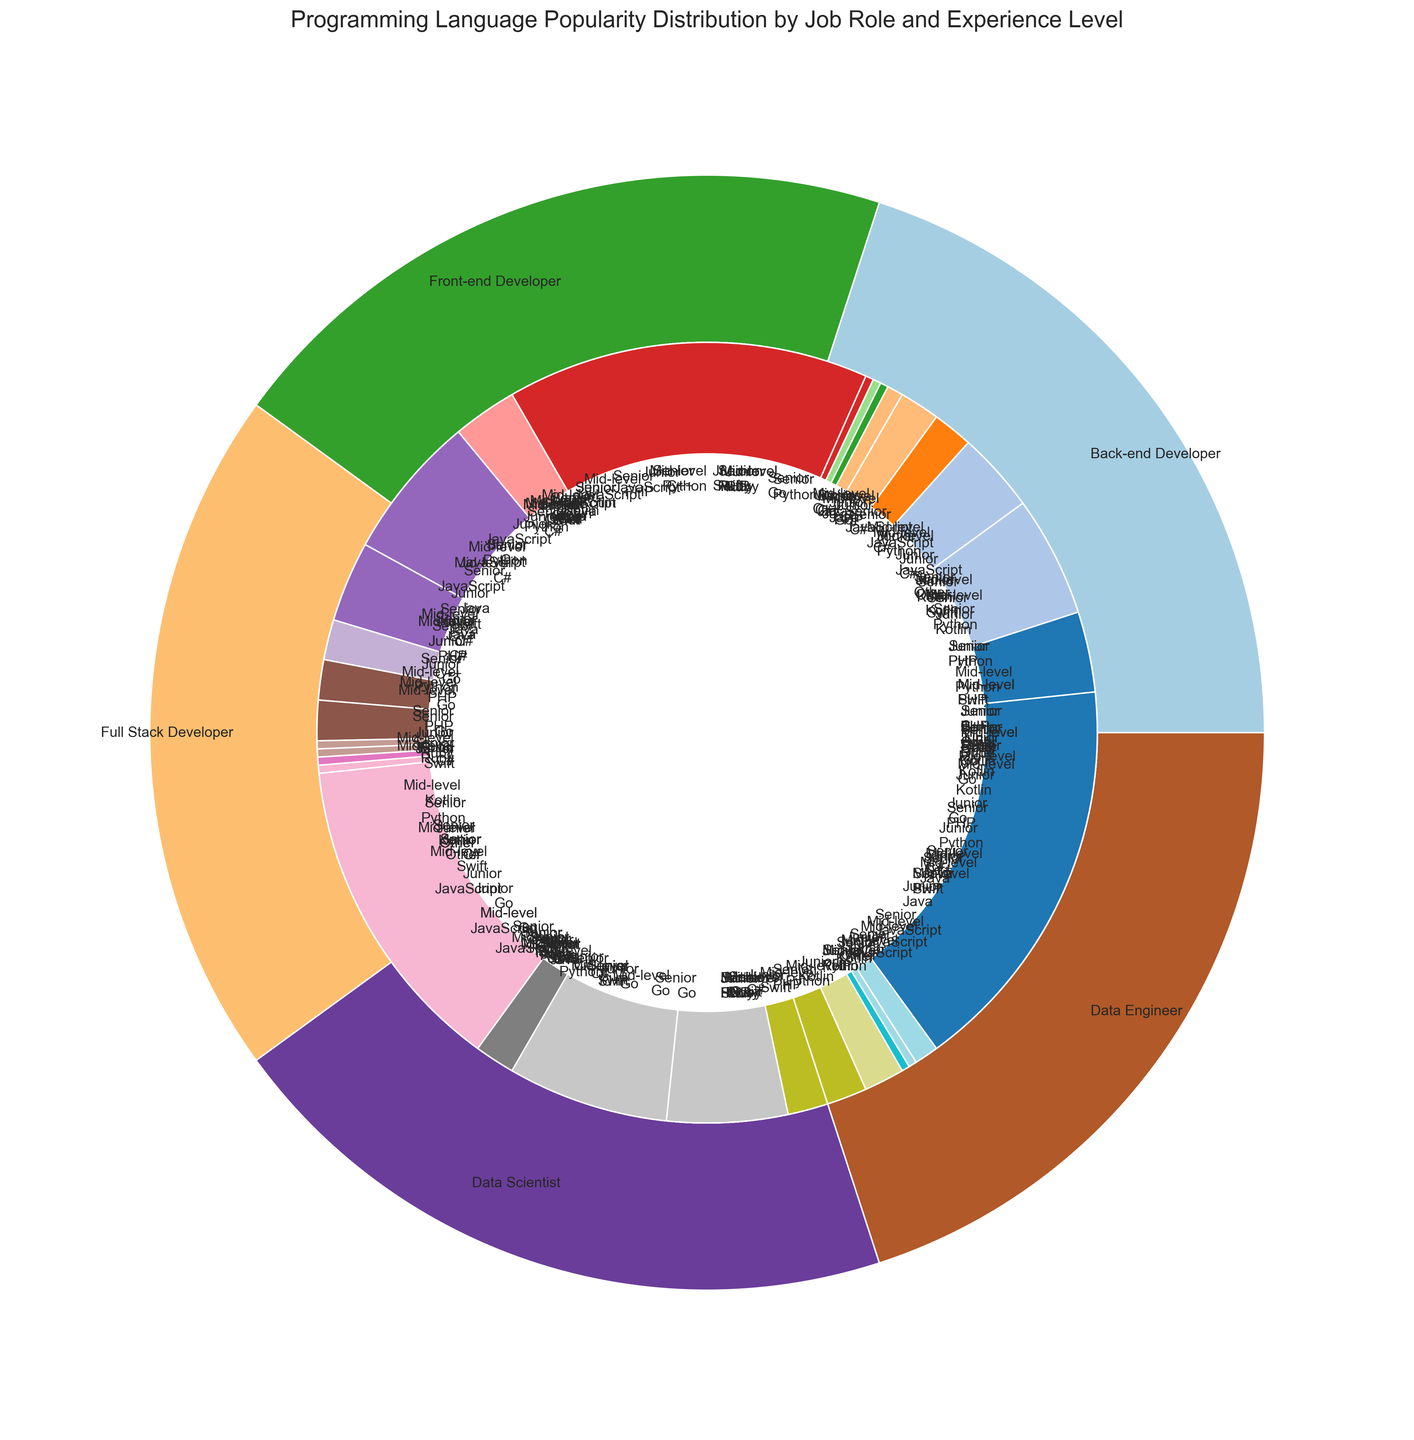Which job role has the most usage of Python for Junior developers? Look at the inner circle segments for Junior developers across different job roles and compare their sizes. The largest segment for Python is under Data Scientist.
Answer: Data Scientist How does the popularity of JavaScript as a language compare between Senior Front-end Developers and Mid-level Front-end Developers? Locate the inner circle segments for Front-end Developers at Senior and Mid-level experience levels. Compare the segments for JavaScript. JavaScript for Senior Front-end Developers is higher.
Answer: Senior more than Mid-level Which job role has the highest total usage of the languages categorized as "Other"? Sum the inner circle segments corresponding to "Other" for all job roles and compare. Data Engineer at Senior level has the largest segment labeled as Other.
Answer: Data Engineer (Senior) What is the combined usage of JavaScript and Python among Junior Back-end Developers? Locate the inner segments for Back-end Developers at Junior level. Add the values for JavaScript (20) and Python (30).
Answer: 50 Between Junior Data Scientists and Junior Data Engineers, which role uses Swift more and by how much? Locate the inner segments for Swift under Junior developers for both Data Scientist and Data Engineer roles. Swift usage is 1 for both roles.
Answer: Same (0 difference) Which language is preferred by Senior Full Stack Developers over Senior Back-end Developers? Compare the inner circle segments of Full Stack Developers and Back-end Developers at the Senior level. Identify the segment that is larger in Full Stack than in Back-end. Java has higher usage in Full Stack (30) compared to Back-end (25).
Answer: Java What is the average usage of C++ among Mid-level developers across all job roles? Find the segments representing C++ among Mid-level developers across all job roles and compute the average. Data points: 10 (Back-end) + 2 (Front-end) + 10 (Full Stack) + 5 (Data Scientist) + 10 (Data Engineer) = 37. Average is 37/5 = 7.4.
Answer: 7.4 How does the preference for Kotlin change from Mid-level to Senior Data Engineers? Compare the inner circle segments for Kotlin in Data Engineers at Mid-level (1) and Senior level (3). Senior level has higher Kotlin usage.
Answer: Increases by 2 